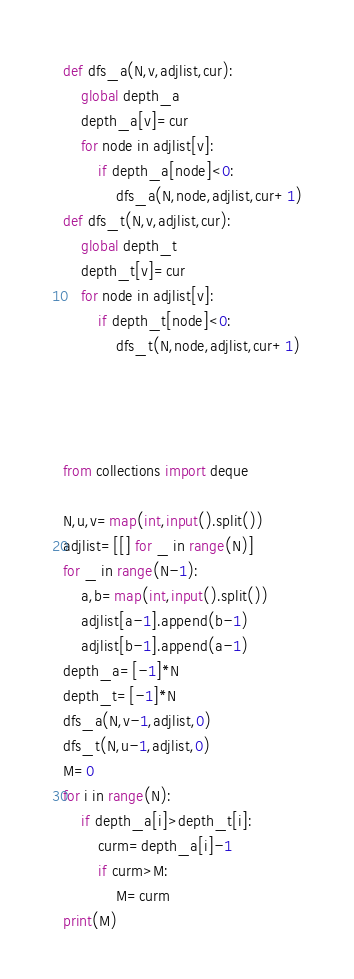<code> <loc_0><loc_0><loc_500><loc_500><_Python_>def dfs_a(N,v,adjlist,cur):
    global depth_a
    depth_a[v]=cur
    for node in adjlist[v]:
        if depth_a[node]<0:
            dfs_a(N,node,adjlist,cur+1)
def dfs_t(N,v,adjlist,cur):
    global depth_t
    depth_t[v]=cur
    for node in adjlist[v]:
        if depth_t[node]<0:
            dfs_t(N,node,adjlist,cur+1)
    
    
    

from collections import deque

N,u,v=map(int,input().split())
adjlist=[[] for _ in range(N)]
for _ in range(N-1):
    a,b=map(int,input().split())
    adjlist[a-1].append(b-1)
    adjlist[b-1].append(a-1)
depth_a=[-1]*N
depth_t=[-1]*N
dfs_a(N,v-1,adjlist,0)
dfs_t(N,u-1,adjlist,0)
M=0
for i in range(N):
    if depth_a[i]>depth_t[i]:
        curm=depth_a[i]-1
        if curm>M:
            M=curm
print(M)</code> 